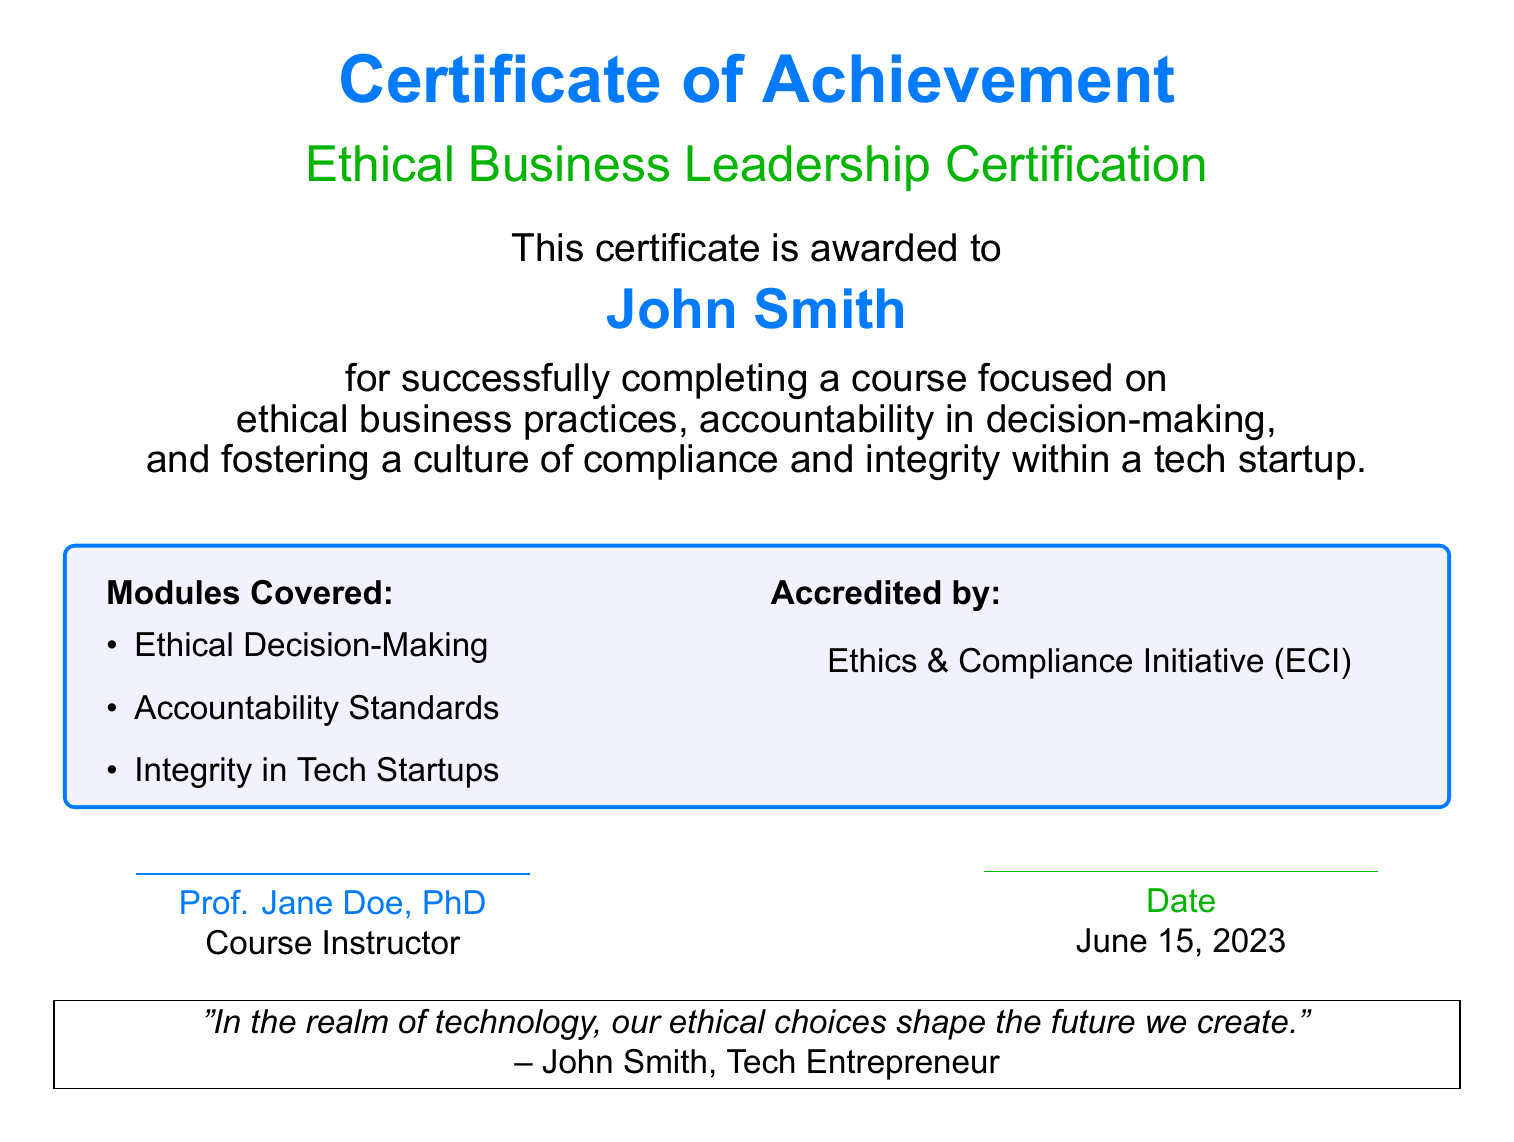What is the title of the certificate? The title indicates the specific achievement recognized by the certificate, which is "Ethical Business Leadership Certification."
Answer: Ethical Business Leadership Certification Who is the certificate awarded to? The content specifies the recipient's name, which is clearly stated on the certificate.
Answer: John Smith What date was the certificate awarded? The document lists the date on which the certificate was issued as part of its formal content.
Answer: June 15, 2023 Which organization accredited the course? The certificate indicates the organization responsible for accrediting the course in the provided context.
Answer: Ethics & Compliance Initiative (ECI) Name one module covered in the course. The document lists several modules included in the course, requiring identification of one.
Answer: Ethical Decision-Making What is the name of the course instructor? The certificate identifies the individual responsible for instructing the course, which is an important detail.
Answer: Prof. Jane Doe, PhD What quote is attributed to John Smith? The document includes a statement or quote from the recipient, reflecting the importance of ethics in technology.
Answer: "In the realm of technology, our ethical choices shape the future we create." How many modules are covered in total? The document lists modules in a bullet point format, allowing for a count based on the items displayed.
Answer: 3 